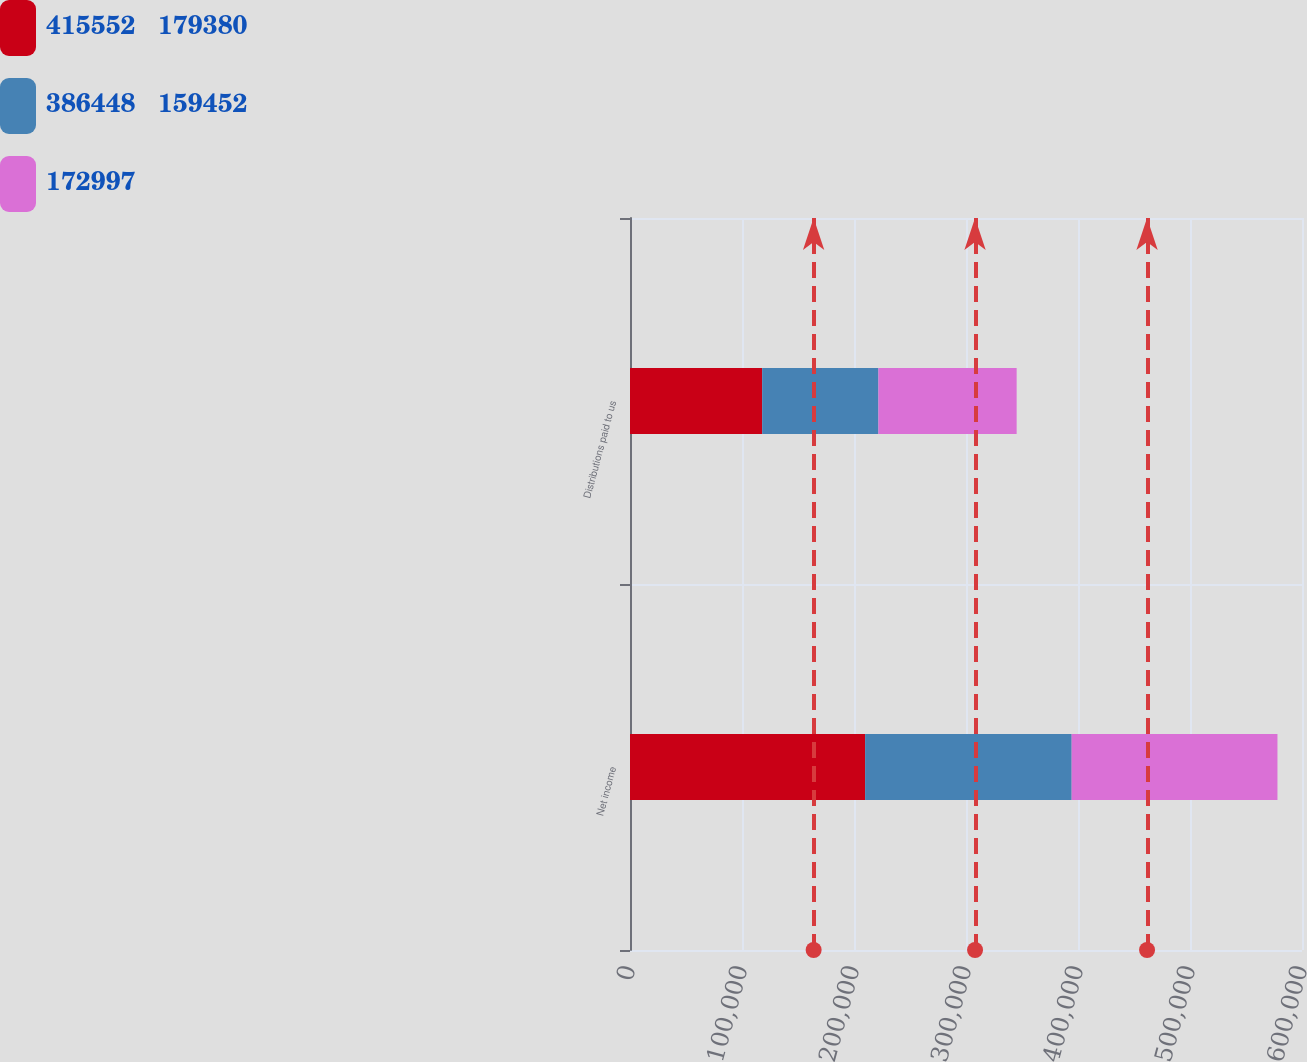Convert chart to OTSL. <chart><loc_0><loc_0><loc_500><loc_500><stacked_bar_chart><ecel><fcel>Net income<fcel>Distributions paid to us<nl><fcel>415552   179380<fcel>209915<fcel>118010<nl><fcel>386448   159452<fcel>184434<fcel>103785<nl><fcel>172997<fcel>183732<fcel>123427<nl></chart> 